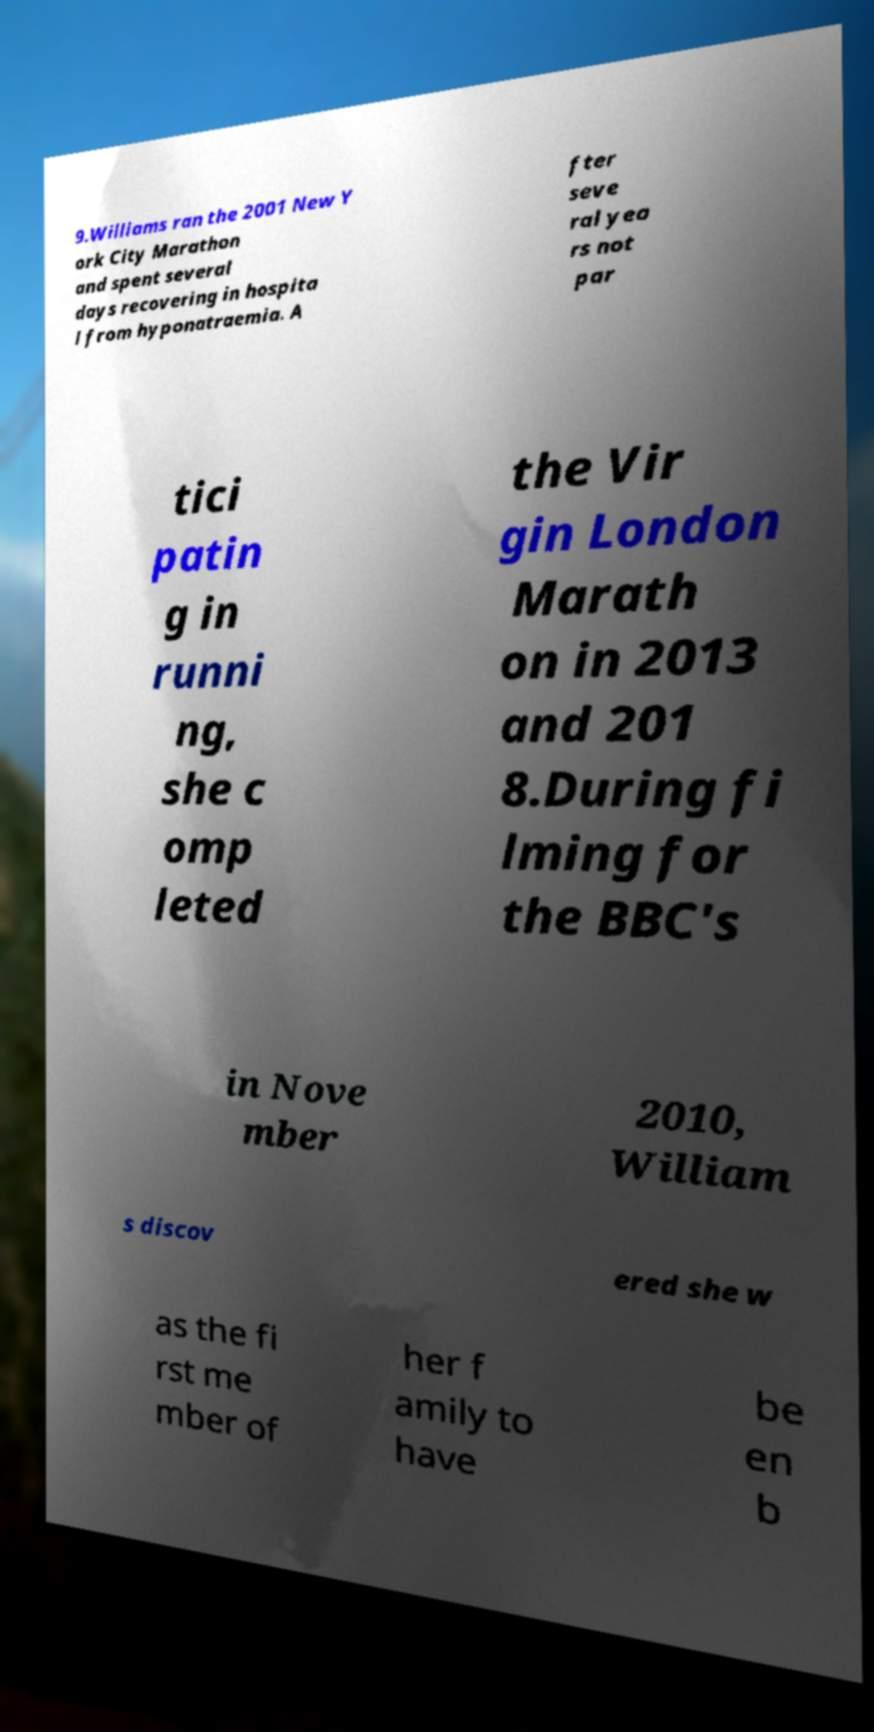What messages or text are displayed in this image? I need them in a readable, typed format. 9.Williams ran the 2001 New Y ork City Marathon and spent several days recovering in hospita l from hyponatraemia. A fter seve ral yea rs not par tici patin g in runni ng, she c omp leted the Vir gin London Marath on in 2013 and 201 8.During fi lming for the BBC's in Nove mber 2010, William s discov ered she w as the fi rst me mber of her f amily to have be en b 